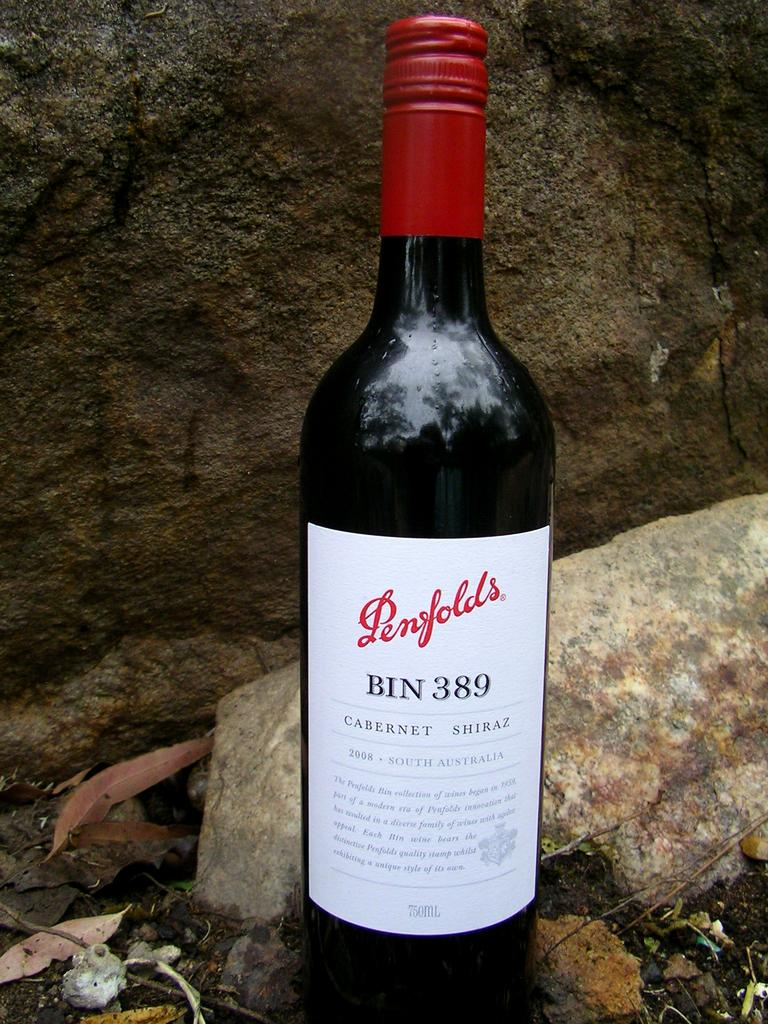<image>
Create a compact narrative representing the image presented. A bottle of Penfolds wine from South Australia. 